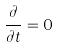Convert formula to latex. <formula><loc_0><loc_0><loc_500><loc_500>\frac { \partial } { \partial t } = 0</formula> 